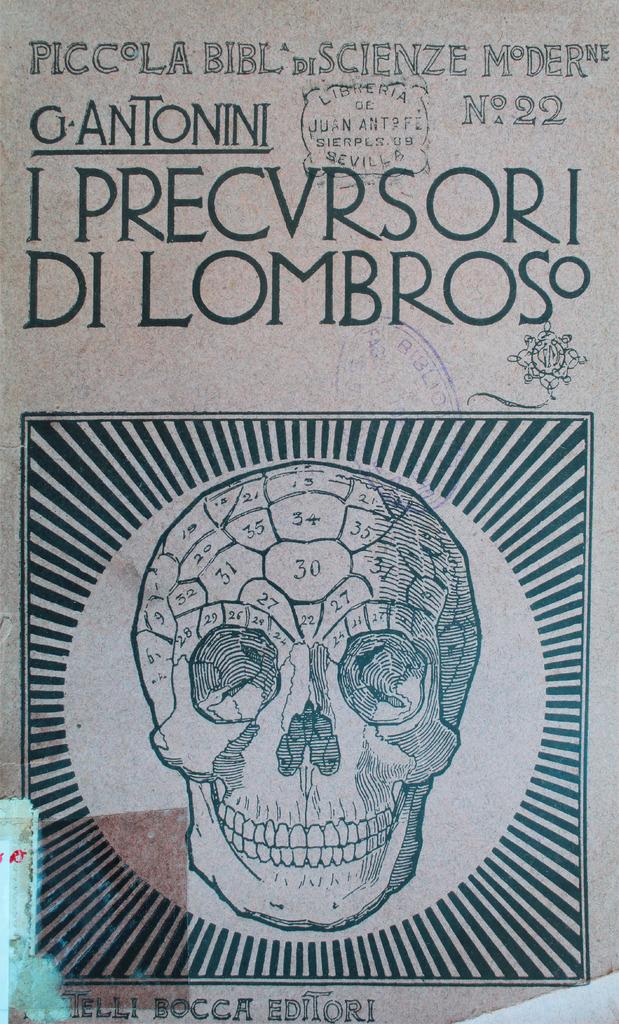Who's the author?
Your response must be concise. G antonini. What number is this issue?
Your response must be concise. 22. 